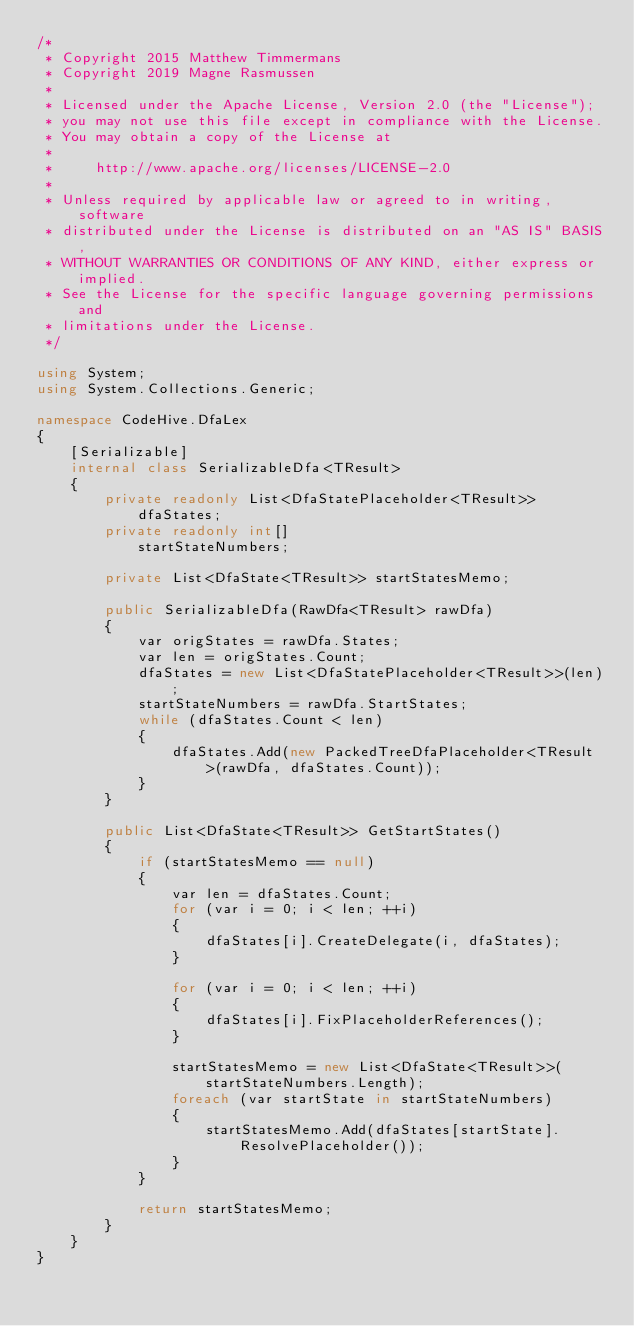<code> <loc_0><loc_0><loc_500><loc_500><_C#_>/*
 * Copyright 2015 Matthew Timmermans
 * Copyright 2019 Magne Rasmussen
 *
 * Licensed under the Apache License, Version 2.0 (the "License");
 * you may not use this file except in compliance with the License.
 * You may obtain a copy of the License at
 *
 *     http://www.apache.org/licenses/LICENSE-2.0
 *
 * Unless required by applicable law or agreed to in writing, software
 * distributed under the License is distributed on an "AS IS" BASIS,
 * WITHOUT WARRANTIES OR CONDITIONS OF ANY KIND, either express or implied.
 * See the License for the specific language governing permissions and
 * limitations under the License.
 */

using System;
using System.Collections.Generic;

namespace CodeHive.DfaLex
{
    [Serializable]
    internal class SerializableDfa<TResult>
    {
        private readonly List<DfaStatePlaceholder<TResult>> dfaStates;
        private readonly int[]                              startStateNumbers;

        private List<DfaState<TResult>> startStatesMemo;

        public SerializableDfa(RawDfa<TResult> rawDfa)
        {
            var origStates = rawDfa.States;
            var len = origStates.Count;
            dfaStates = new List<DfaStatePlaceholder<TResult>>(len);
            startStateNumbers = rawDfa.StartStates;
            while (dfaStates.Count < len)
            {
                dfaStates.Add(new PackedTreeDfaPlaceholder<TResult>(rawDfa, dfaStates.Count));
            }
        }

        public List<DfaState<TResult>> GetStartStates()
        {
            if (startStatesMemo == null)
            {
                var len = dfaStates.Count;
                for (var i = 0; i < len; ++i)
                {
                    dfaStates[i].CreateDelegate(i, dfaStates);
                }

                for (var i = 0; i < len; ++i)
                {
                    dfaStates[i].FixPlaceholderReferences();
                }

                startStatesMemo = new List<DfaState<TResult>>(startStateNumbers.Length);
                foreach (var startState in startStateNumbers)
                {
                    startStatesMemo.Add(dfaStates[startState].ResolvePlaceholder());
                }
            }

            return startStatesMemo;
        }
    }
}
</code> 